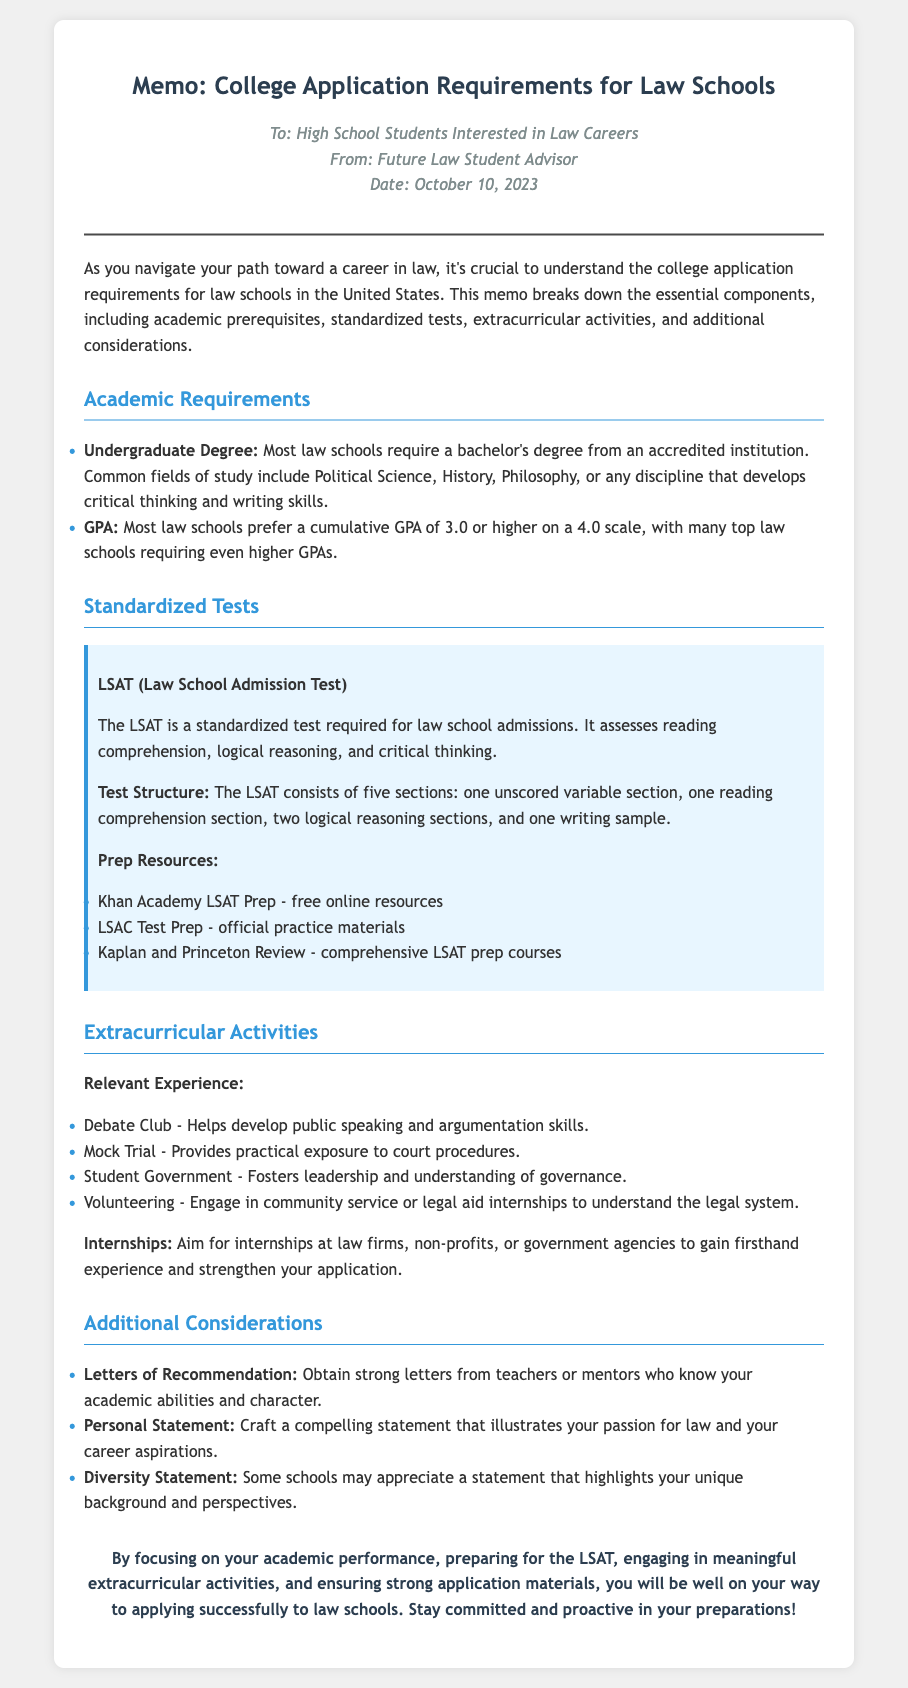What is the required GPA for most law schools? The memo states that most law schools prefer a cumulative GPA of 3.0 or higher on a 4.0 scale.
Answer: 3.0 What standardized test is required for law school admissions? The document specifies the LSAT (Law School Admission Test) as a requirement for law school admissions.
Answer: LSAT What extracurricular activity helps develop public speaking skills? The memo mentions the Debate Club as an activity that helps develop public speaking and argumentation skills.
Answer: Debate Club How many sections are in the LSAT? The document outlines that the LSAT consists of five sections.
Answer: Five What type of internship is recommended for law school applicants? The memo suggests aiming for internships at law firms, non-profits, or government agencies.
Answer: Law firms What should letters of recommendation highlight? The memo indicates that strong letters should reflect the applicant's academic abilities and character.
Answer: Academic abilities and character What is a useful prep resource for the LSAT? The document lists Khan Academy LSAT Prep as a free online resource for LSAT preparation.
Answer: Khan Academy LSAT Prep What is one component of the personal statement? The memo states that the personal statement should illustrate the applicant's passion for law.
Answer: Passion for law What is a unique statement that some schools appreciate? The document mentions a Diversity Statement as one that some schools may appreciate.
Answer: Diversity Statement 